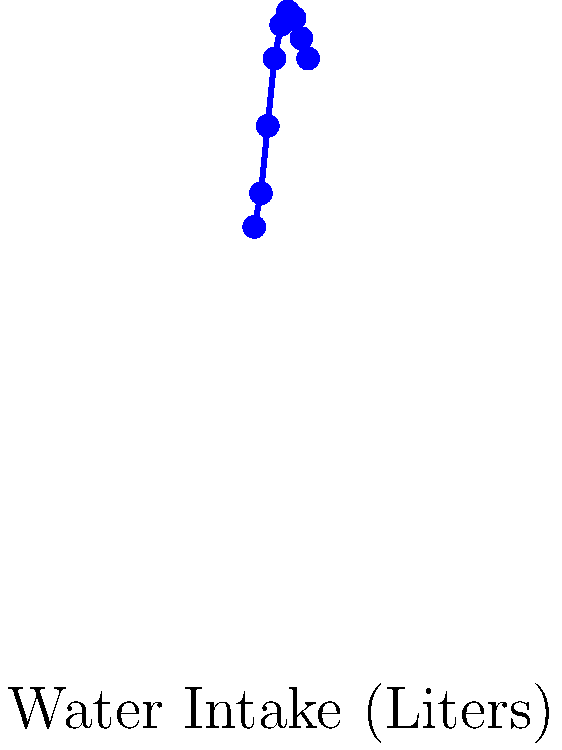Based on the chart showing the relationship between water intake and voice quality for performers, at what level of hydration (in liters) does voice quality reach its peak? To determine the optimal hydration level for vocal health:

1. Observe the graph's x-axis (Water Intake in Liters) and y-axis (Voice Quality %).
2. Identify the highest point on the curve, which represents peak voice quality.
3. The highest point occurs at 5 liters of water intake.
4. At this point, the voice quality reaches 92%.
5. After 5 liters, the graph shows a slight decline in voice quality.
6. This suggests that 5 liters is the optimal hydration level for maintaining vocal health.

The graph demonstrates that increasing water intake generally improves voice quality up to a certain point (5 liters), after which the benefits plateau or slightly decrease. This information is crucial for a drama student focusing on vocal health, as it provides a clear target for daily water consumption to maintain optimal vocal performance.
Answer: 5 liters 